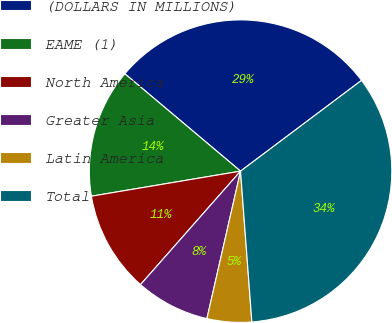Convert chart to OTSL. <chart><loc_0><loc_0><loc_500><loc_500><pie_chart><fcel>(DOLLARS IN MILLIONS)<fcel>EAME (1)<fcel>North America<fcel>Greater Asia<fcel>Latin America<fcel>Total<nl><fcel>28.62%<fcel>13.78%<fcel>10.85%<fcel>7.93%<fcel>4.76%<fcel>34.05%<nl></chart> 